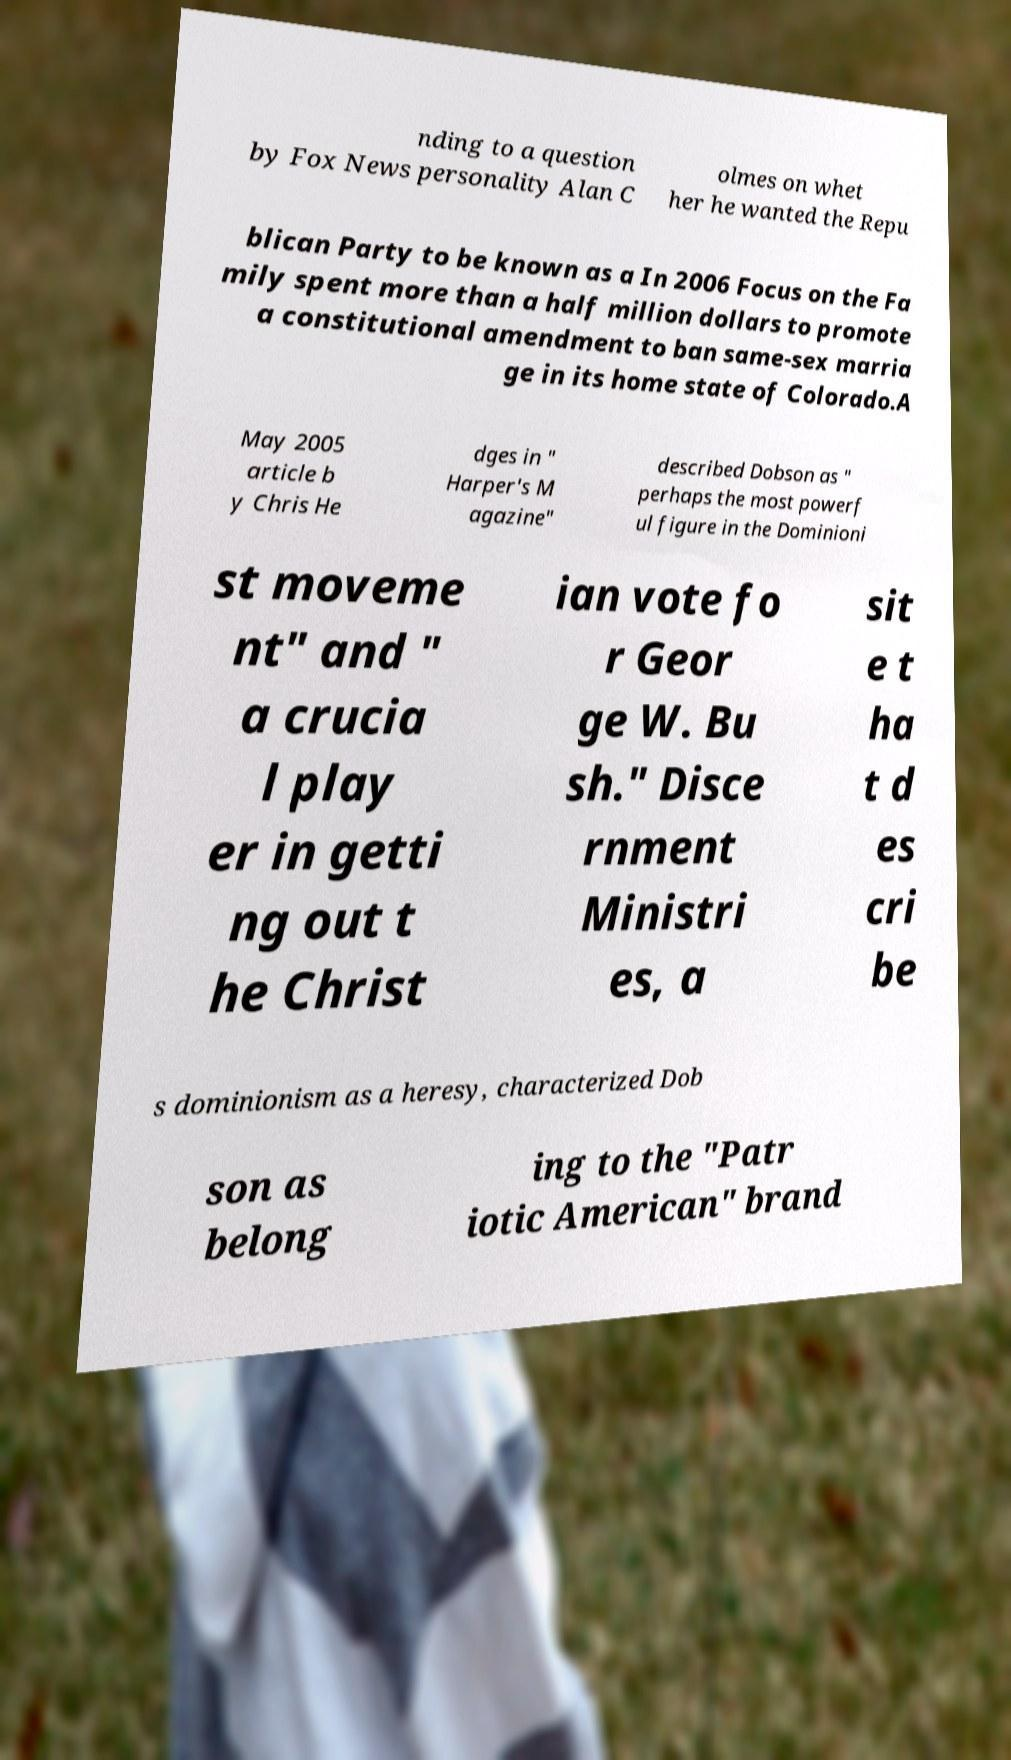There's text embedded in this image that I need extracted. Can you transcribe it verbatim? nding to a question by Fox News personality Alan C olmes on whet her he wanted the Repu blican Party to be known as a In 2006 Focus on the Fa mily spent more than a half million dollars to promote a constitutional amendment to ban same-sex marria ge in its home state of Colorado.A May 2005 article b y Chris He dges in " Harper's M agazine" described Dobson as " perhaps the most powerf ul figure in the Dominioni st moveme nt" and " a crucia l play er in getti ng out t he Christ ian vote fo r Geor ge W. Bu sh." Disce rnment Ministri es, a sit e t ha t d es cri be s dominionism as a heresy, characterized Dob son as belong ing to the "Patr iotic American" brand 